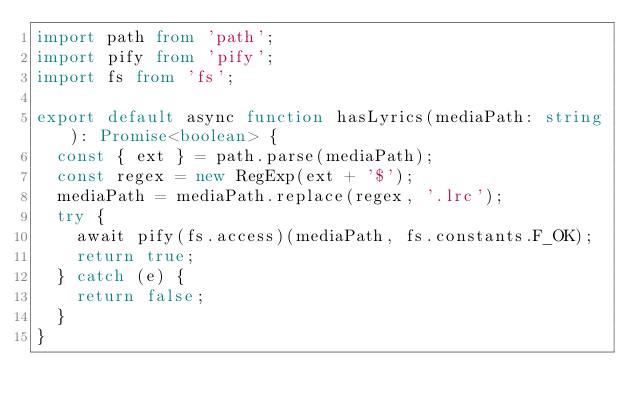Convert code to text. <code><loc_0><loc_0><loc_500><loc_500><_TypeScript_>import path from 'path';
import pify from 'pify';
import fs from 'fs';

export default async function hasLyrics(mediaPath: string): Promise<boolean> {
  const { ext } = path.parse(mediaPath);
  const regex = new RegExp(ext + '$');
  mediaPath = mediaPath.replace(regex, '.lrc');
  try {
    await pify(fs.access)(mediaPath, fs.constants.F_OK);
    return true;
  } catch (e) {
    return false;
  }
}
</code> 